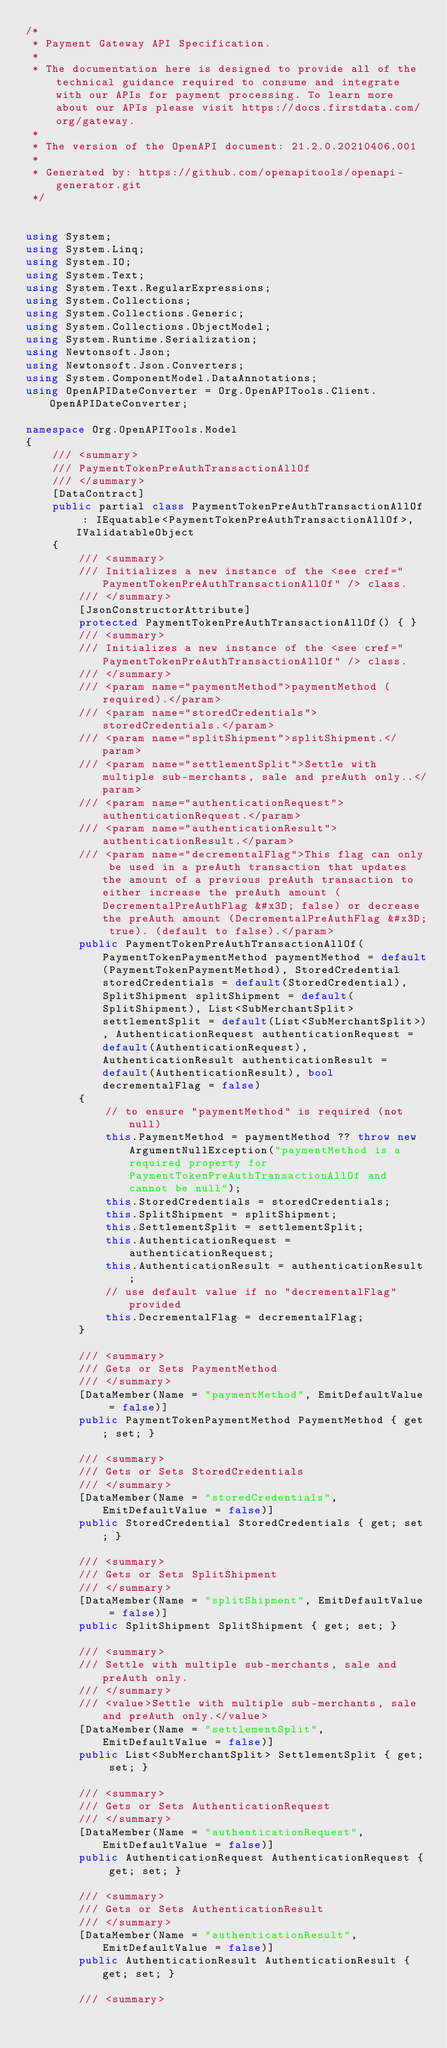Convert code to text. <code><loc_0><loc_0><loc_500><loc_500><_C#_>/* 
 * Payment Gateway API Specification.
 *
 * The documentation here is designed to provide all of the technical guidance required to consume and integrate with our APIs for payment processing. To learn more about our APIs please visit https://docs.firstdata.com/org/gateway.
 *
 * The version of the OpenAPI document: 21.2.0.20210406.001
 * 
 * Generated by: https://github.com/openapitools/openapi-generator.git
 */


using System;
using System.Linq;
using System.IO;
using System.Text;
using System.Text.RegularExpressions;
using System.Collections;
using System.Collections.Generic;
using System.Collections.ObjectModel;
using System.Runtime.Serialization;
using Newtonsoft.Json;
using Newtonsoft.Json.Converters;
using System.ComponentModel.DataAnnotations;
using OpenAPIDateConverter = Org.OpenAPITools.Client.OpenAPIDateConverter;

namespace Org.OpenAPITools.Model
{
    /// <summary>
    /// PaymentTokenPreAuthTransactionAllOf
    /// </summary>
    [DataContract]
    public partial class PaymentTokenPreAuthTransactionAllOf : IEquatable<PaymentTokenPreAuthTransactionAllOf>, IValidatableObject
    {
        /// <summary>
        /// Initializes a new instance of the <see cref="PaymentTokenPreAuthTransactionAllOf" /> class.
        /// </summary>
        [JsonConstructorAttribute]
        protected PaymentTokenPreAuthTransactionAllOf() { }
        /// <summary>
        /// Initializes a new instance of the <see cref="PaymentTokenPreAuthTransactionAllOf" /> class.
        /// </summary>
        /// <param name="paymentMethod">paymentMethod (required).</param>
        /// <param name="storedCredentials">storedCredentials.</param>
        /// <param name="splitShipment">splitShipment.</param>
        /// <param name="settlementSplit">Settle with multiple sub-merchants, sale and preAuth only..</param>
        /// <param name="authenticationRequest">authenticationRequest.</param>
        /// <param name="authenticationResult">authenticationResult.</param>
        /// <param name="decrementalFlag">This flag can only be used in a preAuth transaction that updates the amount of a previous preAuth transaction to either increase the preAuth amount (DecrementalPreAuthFlag &#x3D; false) or decrease the preAuth amount (DecrementalPreAuthFlag &#x3D; true). (default to false).</param>
        public PaymentTokenPreAuthTransactionAllOf(PaymentTokenPaymentMethod paymentMethod = default(PaymentTokenPaymentMethod), StoredCredential storedCredentials = default(StoredCredential), SplitShipment splitShipment = default(SplitShipment), List<SubMerchantSplit> settlementSplit = default(List<SubMerchantSplit>), AuthenticationRequest authenticationRequest = default(AuthenticationRequest), AuthenticationResult authenticationResult = default(AuthenticationResult), bool decrementalFlag = false)
        {
            // to ensure "paymentMethod" is required (not null)
            this.PaymentMethod = paymentMethod ?? throw new ArgumentNullException("paymentMethod is a required property for PaymentTokenPreAuthTransactionAllOf and cannot be null");
            this.StoredCredentials = storedCredentials;
            this.SplitShipment = splitShipment;
            this.SettlementSplit = settlementSplit;
            this.AuthenticationRequest = authenticationRequest;
            this.AuthenticationResult = authenticationResult;
            // use default value if no "decrementalFlag" provided
            this.DecrementalFlag = decrementalFlag;
        }

        /// <summary>
        /// Gets or Sets PaymentMethod
        /// </summary>
        [DataMember(Name = "paymentMethod", EmitDefaultValue = false)]
        public PaymentTokenPaymentMethod PaymentMethod { get; set; }

        /// <summary>
        /// Gets or Sets StoredCredentials
        /// </summary>
        [DataMember(Name = "storedCredentials", EmitDefaultValue = false)]
        public StoredCredential StoredCredentials { get; set; }

        /// <summary>
        /// Gets or Sets SplitShipment
        /// </summary>
        [DataMember(Name = "splitShipment", EmitDefaultValue = false)]
        public SplitShipment SplitShipment { get; set; }

        /// <summary>
        /// Settle with multiple sub-merchants, sale and preAuth only.
        /// </summary>
        /// <value>Settle with multiple sub-merchants, sale and preAuth only.</value>
        [DataMember(Name = "settlementSplit", EmitDefaultValue = false)]
        public List<SubMerchantSplit> SettlementSplit { get; set; }

        /// <summary>
        /// Gets or Sets AuthenticationRequest
        /// </summary>
        [DataMember(Name = "authenticationRequest", EmitDefaultValue = false)]
        public AuthenticationRequest AuthenticationRequest { get; set; }

        /// <summary>
        /// Gets or Sets AuthenticationResult
        /// </summary>
        [DataMember(Name = "authenticationResult", EmitDefaultValue = false)]
        public AuthenticationResult AuthenticationResult { get; set; }

        /// <summary></code> 